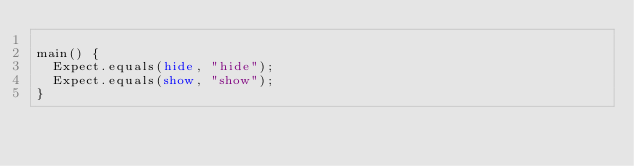Convert code to text. <code><loc_0><loc_0><loc_500><loc_500><_Dart_>
main() {
  Expect.equals(hide, "hide");
  Expect.equals(show, "show");
}
</code> 